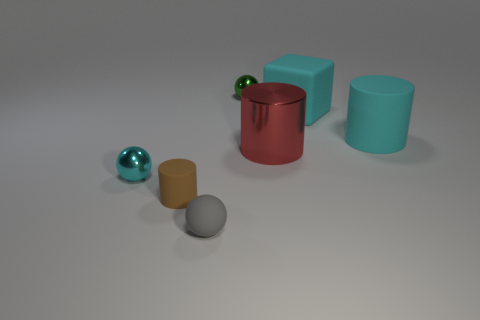Which objects in the image have a similar shape but different textures? Observing the shapes and textures in the image, the red cylinder and the tan cylinder have identical shapes but different textures; one has a matte finish and the other has a shiny surface. And which two are the most similar in texture but different in color? With respect to texture, the two spheres—one grey and the other teal—look the most similar. They both exhibit a smooth, matte finish but are different in color. 